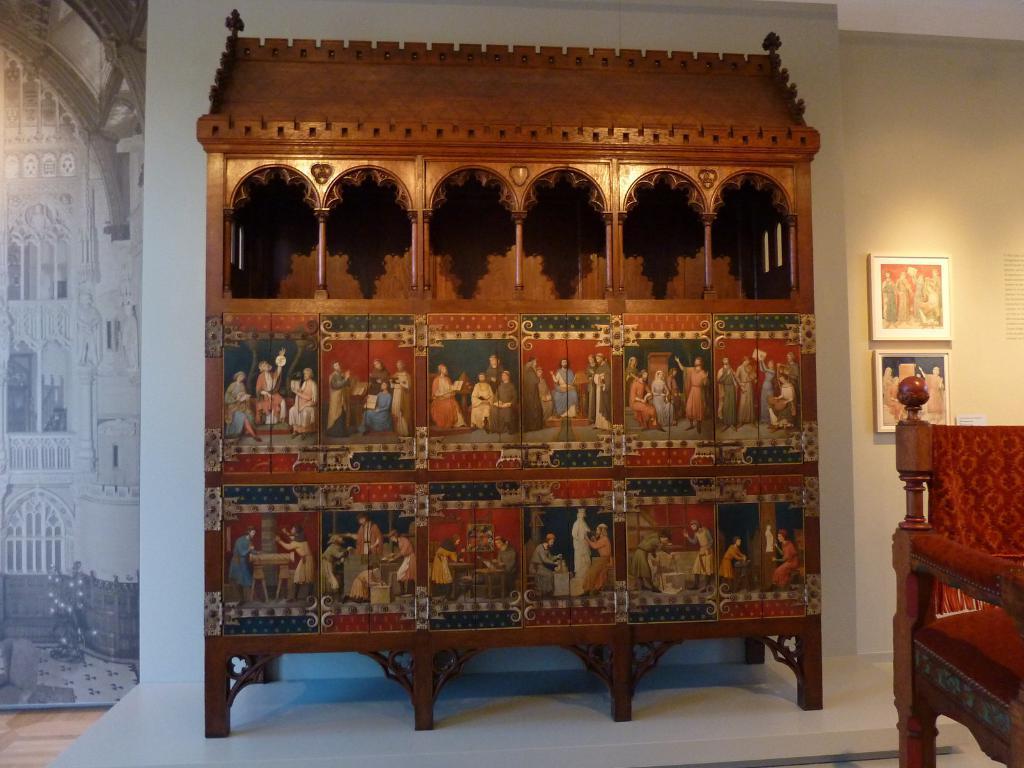Describe this image in one or two sentences. In the picture we can see a wooden rack with some designs to it and besides to it, we can see a wooden chair and into the wall we can see photo frames. 